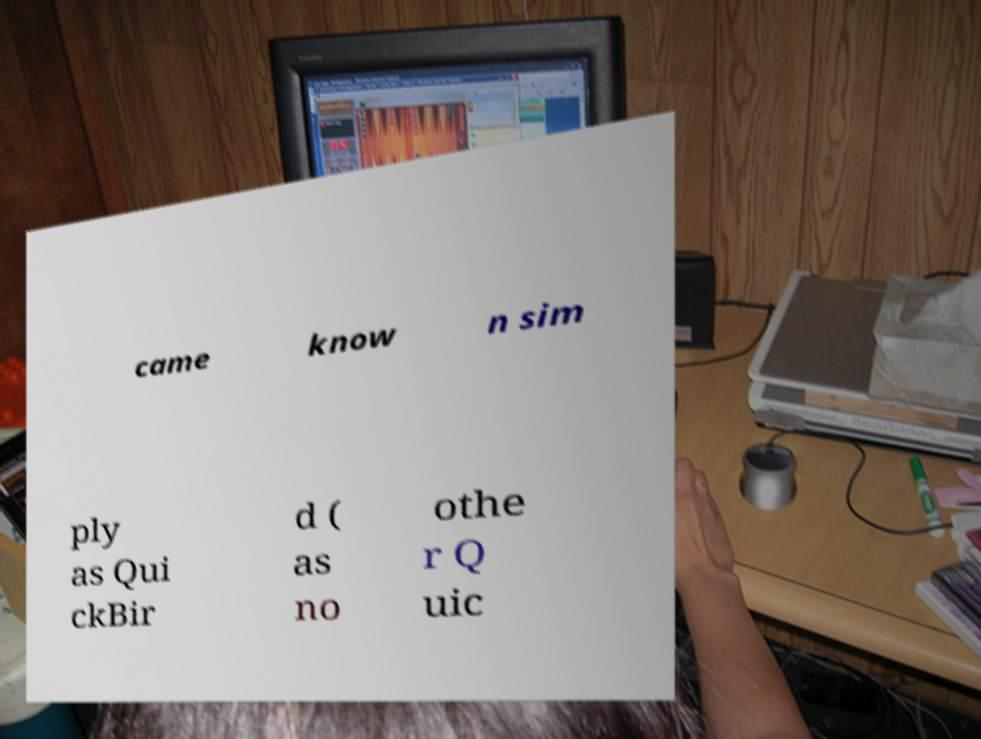Please identify and transcribe the text found in this image. came know n sim ply as Qui ckBir d ( as no othe r Q uic 